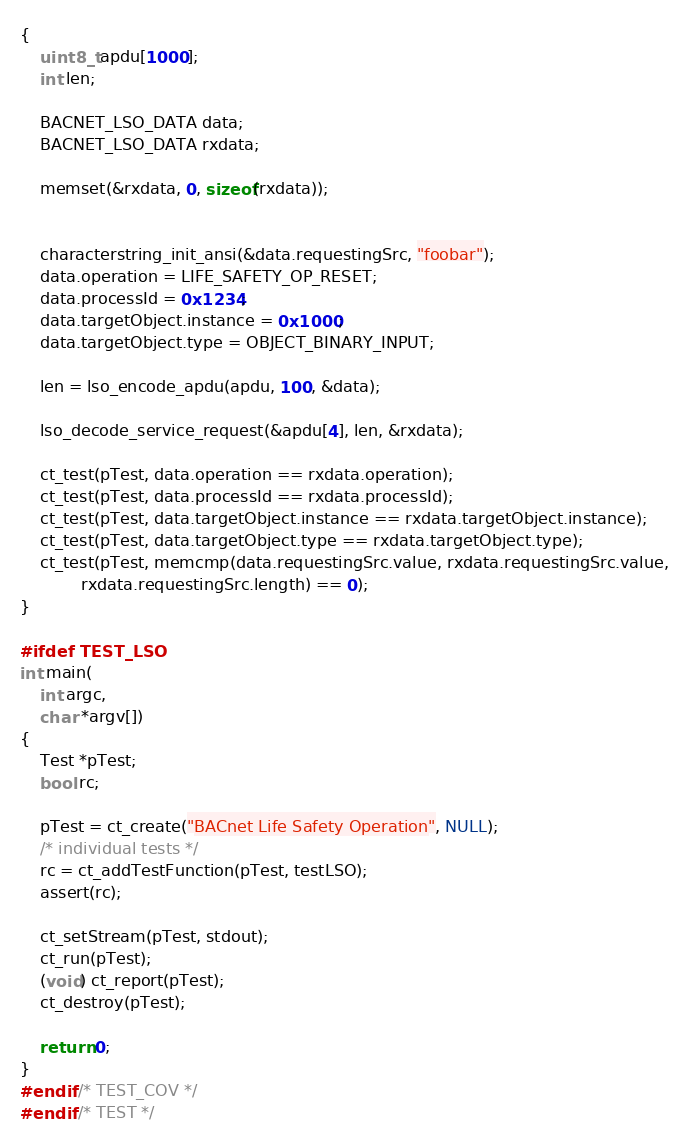<code> <loc_0><loc_0><loc_500><loc_500><_C_>{
    uint8_t apdu[1000];
    int len;

    BACNET_LSO_DATA data;
    BACNET_LSO_DATA rxdata;

    memset(&rxdata, 0, sizeof(rxdata));


    characterstring_init_ansi(&data.requestingSrc, "foobar");
    data.operation = LIFE_SAFETY_OP_RESET;
    data.processId = 0x1234;
    data.targetObject.instance = 0x1000;
    data.targetObject.type = OBJECT_BINARY_INPUT;

    len = lso_encode_apdu(apdu, 100, &data);

    lso_decode_service_request(&apdu[4], len, &rxdata);

    ct_test(pTest, data.operation == rxdata.operation);
    ct_test(pTest, data.processId == rxdata.processId);
    ct_test(pTest, data.targetObject.instance == rxdata.targetObject.instance);
    ct_test(pTest, data.targetObject.type == rxdata.targetObject.type);
    ct_test(pTest, memcmp(data.requestingSrc.value, rxdata.requestingSrc.value,
            rxdata.requestingSrc.length) == 0);
}

#ifdef TEST_LSO
int main(
    int argc,
    char *argv[])
{
    Test *pTest;
    bool rc;

    pTest = ct_create("BACnet Life Safety Operation", NULL);
    /* individual tests */
    rc = ct_addTestFunction(pTest, testLSO);
    assert(rc);

    ct_setStream(pTest, stdout);
    ct_run(pTest);
    (void) ct_report(pTest);
    ct_destroy(pTest);

    return 0;
}
#endif /* TEST_COV */
#endif /* TEST */
</code> 